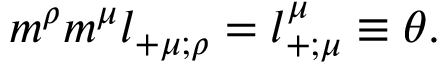<formula> <loc_0><loc_0><loc_500><loc_500>{ m } ^ { \rho } { m } ^ { \mu } l _ { + \mu ; \rho } = l _ { + ; \mu } ^ { \mu } \equiv \theta .</formula> 